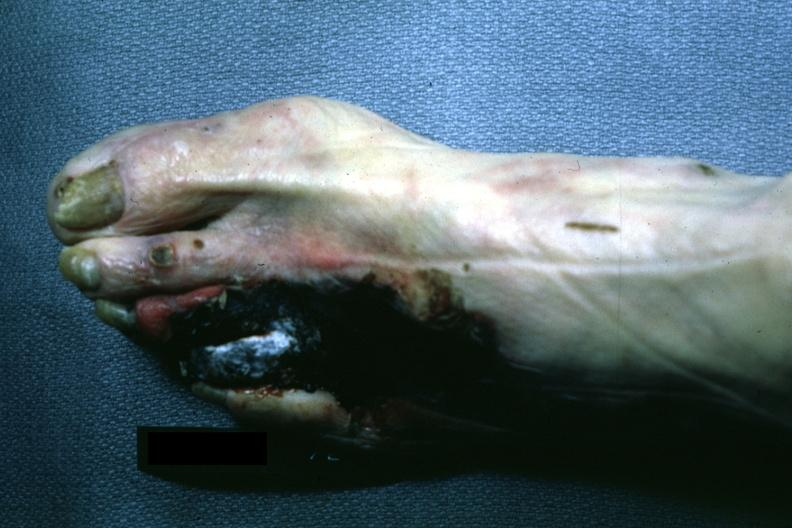re extremities present?
Answer the question using a single word or phrase. Yes 